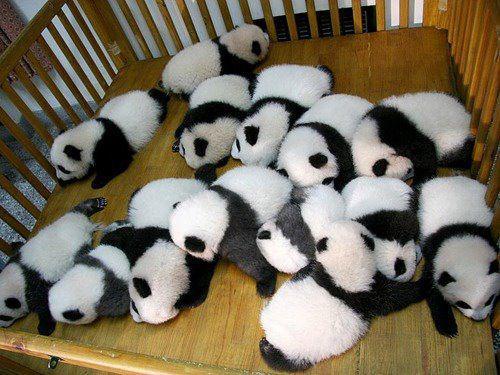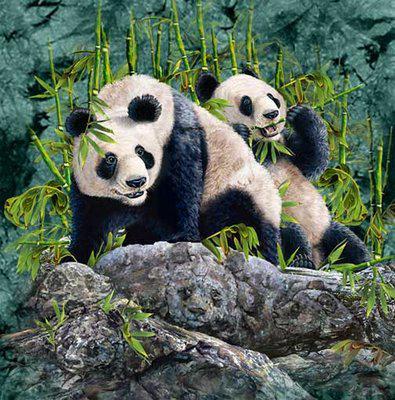The first image is the image on the left, the second image is the image on the right. For the images displayed, is the sentence "The panda in the image to the left is alone." factually correct? Answer yes or no. No. 